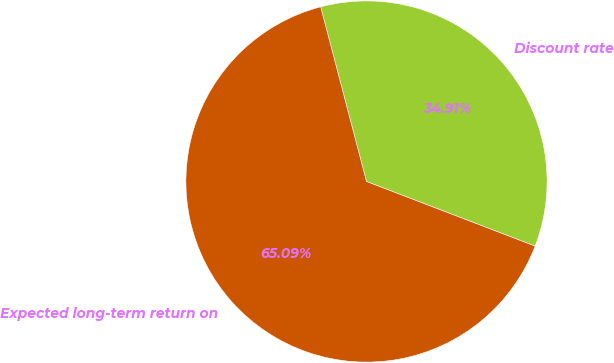Convert chart. <chart><loc_0><loc_0><loc_500><loc_500><pie_chart><fcel>Discount rate<fcel>Expected long-term return on<nl><fcel>34.91%<fcel>65.09%<nl></chart> 